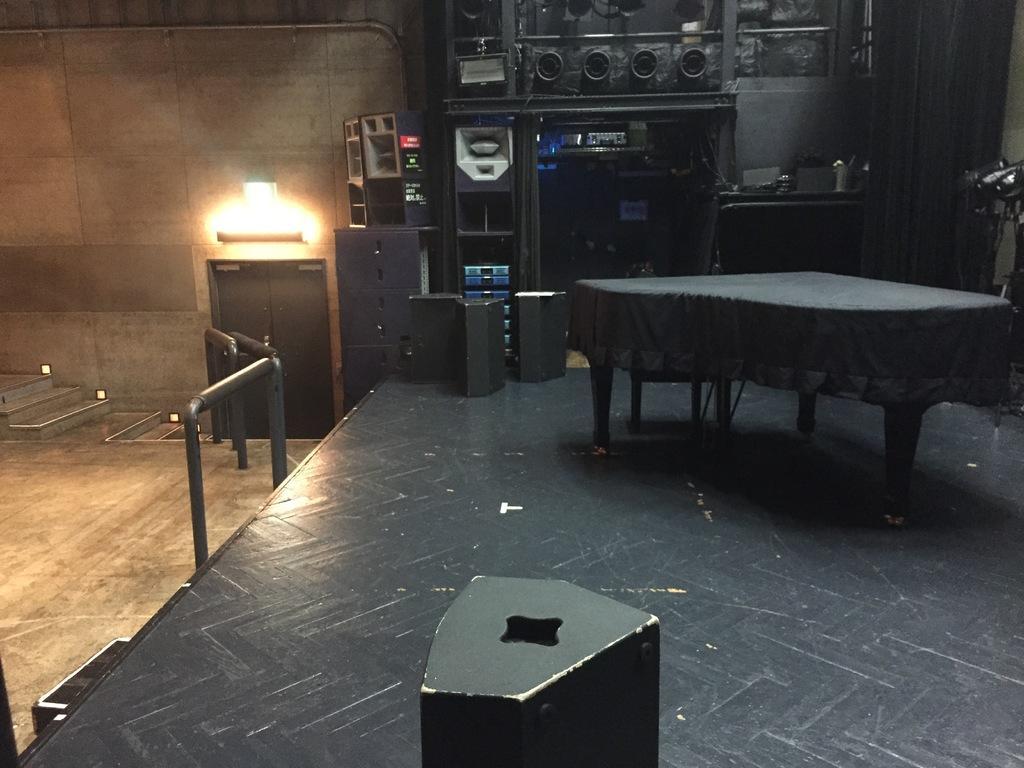Can you describe this image briefly? In this image we can see a table with a black color cloth. In the background of the image there are speakers. At the bottom of the image there is speaker on the floor. To the left side of the image there is a wooden flooring. There is a wall with lights. There is railing. 